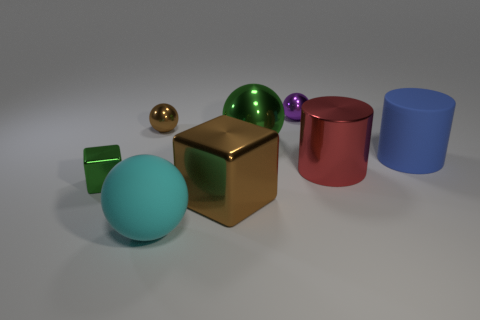Add 1 large cyan rubber spheres. How many objects exist? 9 Subtract all cylinders. How many objects are left? 6 Add 3 tiny red rubber cubes. How many tiny red rubber cubes exist? 3 Subtract 1 red cylinders. How many objects are left? 7 Subtract all big blue matte cylinders. Subtract all purple metallic spheres. How many objects are left? 6 Add 7 large rubber spheres. How many large rubber spheres are left? 8 